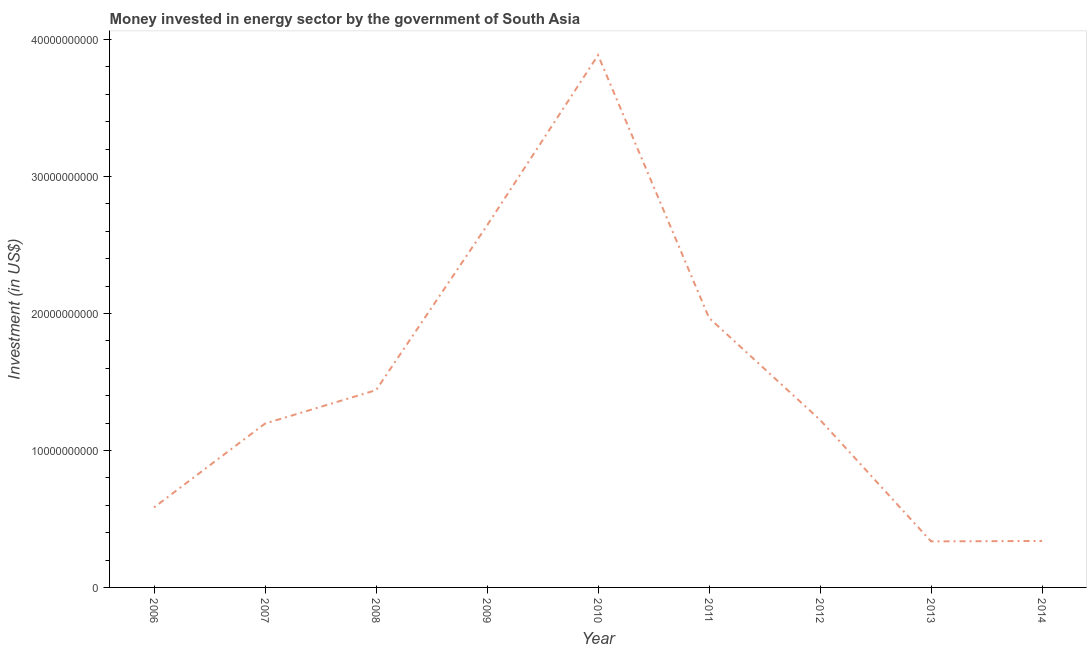What is the investment in energy in 2014?
Offer a very short reply. 3.39e+09. Across all years, what is the maximum investment in energy?
Give a very brief answer. 3.89e+1. Across all years, what is the minimum investment in energy?
Your answer should be compact. 3.36e+09. In which year was the investment in energy minimum?
Offer a terse response. 2013. What is the sum of the investment in energy?
Keep it short and to the point. 1.36e+11. What is the difference between the investment in energy in 2008 and 2009?
Ensure brevity in your answer.  -1.20e+1. What is the average investment in energy per year?
Offer a terse response. 1.51e+1. What is the median investment in energy?
Make the answer very short. 1.22e+1. Do a majority of the years between 2011 and 2014 (inclusive) have investment in energy greater than 8000000000 US$?
Provide a short and direct response. No. What is the ratio of the investment in energy in 2013 to that in 2014?
Offer a very short reply. 0.99. Is the investment in energy in 2006 less than that in 2009?
Provide a succinct answer. Yes. What is the difference between the highest and the second highest investment in energy?
Provide a short and direct response. 1.24e+1. Is the sum of the investment in energy in 2013 and 2014 greater than the maximum investment in energy across all years?
Keep it short and to the point. No. What is the difference between the highest and the lowest investment in energy?
Offer a very short reply. 3.55e+1. Does the investment in energy monotonically increase over the years?
Keep it short and to the point. No. How many lines are there?
Offer a terse response. 1. What is the difference between two consecutive major ticks on the Y-axis?
Ensure brevity in your answer.  1.00e+1. Are the values on the major ticks of Y-axis written in scientific E-notation?
Your response must be concise. No. Does the graph contain any zero values?
Ensure brevity in your answer.  No. Does the graph contain grids?
Make the answer very short. No. What is the title of the graph?
Your response must be concise. Money invested in energy sector by the government of South Asia. What is the label or title of the X-axis?
Ensure brevity in your answer.  Year. What is the label or title of the Y-axis?
Offer a very short reply. Investment (in US$). What is the Investment (in US$) in 2006?
Your answer should be compact. 5.84e+09. What is the Investment (in US$) of 2007?
Provide a short and direct response. 1.20e+1. What is the Investment (in US$) in 2008?
Provide a short and direct response. 1.44e+1. What is the Investment (in US$) in 2009?
Your answer should be very brief. 2.64e+1. What is the Investment (in US$) of 2010?
Keep it short and to the point. 3.89e+1. What is the Investment (in US$) of 2011?
Ensure brevity in your answer.  1.97e+1. What is the Investment (in US$) of 2012?
Your answer should be compact. 1.22e+1. What is the Investment (in US$) of 2013?
Your response must be concise. 3.36e+09. What is the Investment (in US$) of 2014?
Your answer should be very brief. 3.39e+09. What is the difference between the Investment (in US$) in 2006 and 2007?
Keep it short and to the point. -6.12e+09. What is the difference between the Investment (in US$) in 2006 and 2008?
Give a very brief answer. -8.56e+09. What is the difference between the Investment (in US$) in 2006 and 2009?
Your answer should be compact. -2.06e+1. What is the difference between the Investment (in US$) in 2006 and 2010?
Offer a terse response. -3.30e+1. What is the difference between the Investment (in US$) in 2006 and 2011?
Offer a very short reply. -1.38e+1. What is the difference between the Investment (in US$) in 2006 and 2012?
Provide a short and direct response. -6.39e+09. What is the difference between the Investment (in US$) in 2006 and 2013?
Your answer should be very brief. 2.48e+09. What is the difference between the Investment (in US$) in 2006 and 2014?
Keep it short and to the point. 2.45e+09. What is the difference between the Investment (in US$) in 2007 and 2008?
Your response must be concise. -2.44e+09. What is the difference between the Investment (in US$) in 2007 and 2009?
Offer a terse response. -1.45e+1. What is the difference between the Investment (in US$) in 2007 and 2010?
Give a very brief answer. -2.69e+1. What is the difference between the Investment (in US$) in 2007 and 2011?
Keep it short and to the point. -7.71e+09. What is the difference between the Investment (in US$) in 2007 and 2012?
Provide a short and direct response. -2.67e+08. What is the difference between the Investment (in US$) in 2007 and 2013?
Ensure brevity in your answer.  8.60e+09. What is the difference between the Investment (in US$) in 2007 and 2014?
Your answer should be compact. 8.57e+09. What is the difference between the Investment (in US$) in 2008 and 2009?
Offer a terse response. -1.20e+1. What is the difference between the Investment (in US$) in 2008 and 2010?
Offer a very short reply. -2.45e+1. What is the difference between the Investment (in US$) in 2008 and 2011?
Your answer should be very brief. -5.27e+09. What is the difference between the Investment (in US$) in 2008 and 2012?
Provide a short and direct response. 2.17e+09. What is the difference between the Investment (in US$) in 2008 and 2013?
Offer a very short reply. 1.10e+1. What is the difference between the Investment (in US$) in 2008 and 2014?
Ensure brevity in your answer.  1.10e+1. What is the difference between the Investment (in US$) in 2009 and 2010?
Make the answer very short. -1.24e+1. What is the difference between the Investment (in US$) in 2009 and 2011?
Provide a short and direct response. 6.75e+09. What is the difference between the Investment (in US$) in 2009 and 2012?
Offer a terse response. 1.42e+1. What is the difference between the Investment (in US$) in 2009 and 2013?
Provide a succinct answer. 2.31e+1. What is the difference between the Investment (in US$) in 2009 and 2014?
Provide a short and direct response. 2.30e+1. What is the difference between the Investment (in US$) in 2010 and 2011?
Your answer should be compact. 1.92e+1. What is the difference between the Investment (in US$) in 2010 and 2012?
Keep it short and to the point. 2.66e+1. What is the difference between the Investment (in US$) in 2010 and 2013?
Your answer should be compact. 3.55e+1. What is the difference between the Investment (in US$) in 2010 and 2014?
Your answer should be very brief. 3.55e+1. What is the difference between the Investment (in US$) in 2011 and 2012?
Provide a succinct answer. 7.45e+09. What is the difference between the Investment (in US$) in 2011 and 2013?
Offer a very short reply. 1.63e+1. What is the difference between the Investment (in US$) in 2011 and 2014?
Provide a succinct answer. 1.63e+1. What is the difference between the Investment (in US$) in 2012 and 2013?
Your answer should be compact. 8.87e+09. What is the difference between the Investment (in US$) in 2012 and 2014?
Offer a very short reply. 8.84e+09. What is the difference between the Investment (in US$) in 2013 and 2014?
Give a very brief answer. -3.07e+07. What is the ratio of the Investment (in US$) in 2006 to that in 2007?
Provide a short and direct response. 0.49. What is the ratio of the Investment (in US$) in 2006 to that in 2008?
Provide a succinct answer. 0.41. What is the ratio of the Investment (in US$) in 2006 to that in 2009?
Provide a short and direct response. 0.22. What is the ratio of the Investment (in US$) in 2006 to that in 2011?
Your answer should be compact. 0.3. What is the ratio of the Investment (in US$) in 2006 to that in 2012?
Give a very brief answer. 0.48. What is the ratio of the Investment (in US$) in 2006 to that in 2013?
Your response must be concise. 1.74. What is the ratio of the Investment (in US$) in 2006 to that in 2014?
Ensure brevity in your answer.  1.72. What is the ratio of the Investment (in US$) in 2007 to that in 2008?
Provide a succinct answer. 0.83. What is the ratio of the Investment (in US$) in 2007 to that in 2009?
Give a very brief answer. 0.45. What is the ratio of the Investment (in US$) in 2007 to that in 2010?
Offer a terse response. 0.31. What is the ratio of the Investment (in US$) in 2007 to that in 2011?
Ensure brevity in your answer.  0.61. What is the ratio of the Investment (in US$) in 2007 to that in 2013?
Make the answer very short. 3.56. What is the ratio of the Investment (in US$) in 2007 to that in 2014?
Ensure brevity in your answer.  3.53. What is the ratio of the Investment (in US$) in 2008 to that in 2009?
Offer a terse response. 0.55. What is the ratio of the Investment (in US$) in 2008 to that in 2010?
Give a very brief answer. 0.37. What is the ratio of the Investment (in US$) in 2008 to that in 2011?
Provide a succinct answer. 0.73. What is the ratio of the Investment (in US$) in 2008 to that in 2012?
Your answer should be compact. 1.18. What is the ratio of the Investment (in US$) in 2008 to that in 2013?
Ensure brevity in your answer.  4.29. What is the ratio of the Investment (in US$) in 2008 to that in 2014?
Your response must be concise. 4.25. What is the ratio of the Investment (in US$) in 2009 to that in 2010?
Ensure brevity in your answer.  0.68. What is the ratio of the Investment (in US$) in 2009 to that in 2011?
Give a very brief answer. 1.34. What is the ratio of the Investment (in US$) in 2009 to that in 2012?
Keep it short and to the point. 2.16. What is the ratio of the Investment (in US$) in 2009 to that in 2013?
Give a very brief answer. 7.86. What is the ratio of the Investment (in US$) in 2009 to that in 2014?
Your answer should be very brief. 7.79. What is the ratio of the Investment (in US$) in 2010 to that in 2011?
Give a very brief answer. 1.98. What is the ratio of the Investment (in US$) in 2010 to that in 2012?
Offer a terse response. 3.18. What is the ratio of the Investment (in US$) in 2010 to that in 2013?
Offer a terse response. 11.56. What is the ratio of the Investment (in US$) in 2010 to that in 2014?
Keep it short and to the point. 11.46. What is the ratio of the Investment (in US$) in 2011 to that in 2012?
Your response must be concise. 1.61. What is the ratio of the Investment (in US$) in 2011 to that in 2013?
Your response must be concise. 5.85. What is the ratio of the Investment (in US$) in 2011 to that in 2014?
Your answer should be very brief. 5.8. What is the ratio of the Investment (in US$) in 2012 to that in 2013?
Your answer should be very brief. 3.64. What is the ratio of the Investment (in US$) in 2012 to that in 2014?
Keep it short and to the point. 3.61. 